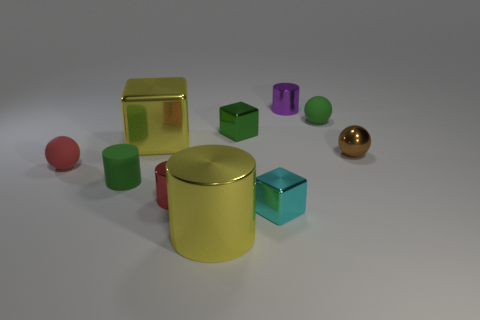Subtract all balls. How many objects are left? 7 Add 6 small green rubber cylinders. How many small green rubber cylinders are left? 7 Add 8 purple things. How many purple things exist? 9 Subtract 0 yellow spheres. How many objects are left? 10 Subtract all green blocks. Subtract all tiny brown rubber spheres. How many objects are left? 9 